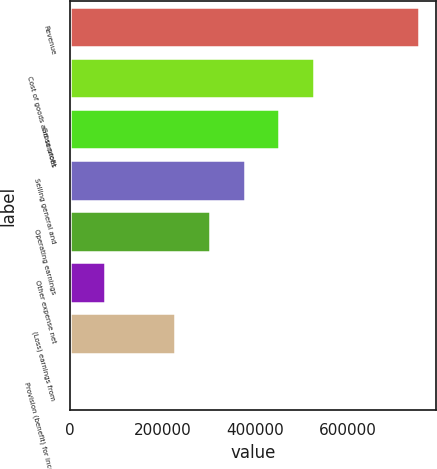Convert chart to OTSL. <chart><loc_0><loc_0><loc_500><loc_500><bar_chart><fcel>Revenue<fcel>Cost of goods and services<fcel>Gross profit<fcel>Selling general and<fcel>Operating earnings<fcel>Other expense net<fcel>(Loss) earnings from<fcel>Provision (benefit) for income<nl><fcel>751808<fcel>526888<fcel>451915<fcel>376942<fcel>301969<fcel>77049.2<fcel>226996<fcel>2076<nl></chart> 